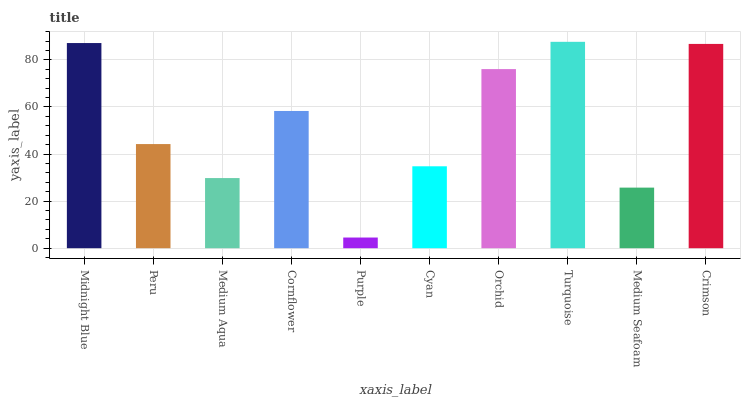Is Purple the minimum?
Answer yes or no. Yes. Is Turquoise the maximum?
Answer yes or no. Yes. Is Peru the minimum?
Answer yes or no. No. Is Peru the maximum?
Answer yes or no. No. Is Midnight Blue greater than Peru?
Answer yes or no. Yes. Is Peru less than Midnight Blue?
Answer yes or no. Yes. Is Peru greater than Midnight Blue?
Answer yes or no. No. Is Midnight Blue less than Peru?
Answer yes or no. No. Is Cornflower the high median?
Answer yes or no. Yes. Is Peru the low median?
Answer yes or no. Yes. Is Orchid the high median?
Answer yes or no. No. Is Cornflower the low median?
Answer yes or no. No. 